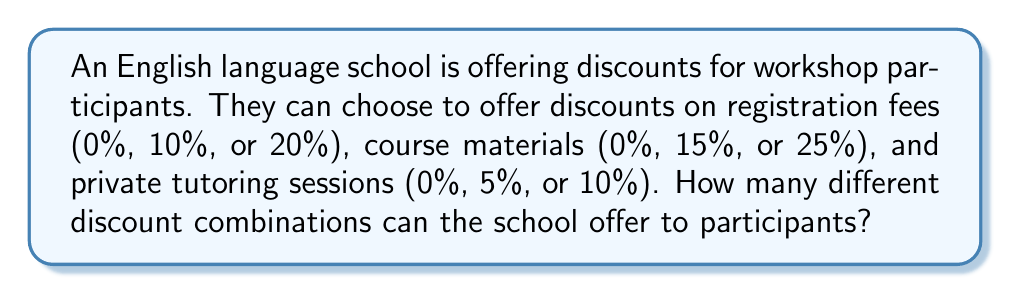Can you answer this question? Let's approach this step-by-step:

1) We need to use the multiplication principle of counting, as we're dealing with independent choices for each discount category.

2) For registration fees:
   There are 3 options: 0%, 10%, or 20%

3) For course materials:
   There are 3 options: 0%, 15%, or 25%

4) For private tutoring sessions:
   There are 3 options: 0%, 5%, or 10%

5) To find the total number of combinations, we multiply the number of options for each category:

   $$ \text{Total combinations} = 3 \times 3 \times 3 = 3^3 = 27 $$

Therefore, the school can offer 27 different discount combinations to workshop participants.
Answer: 27 